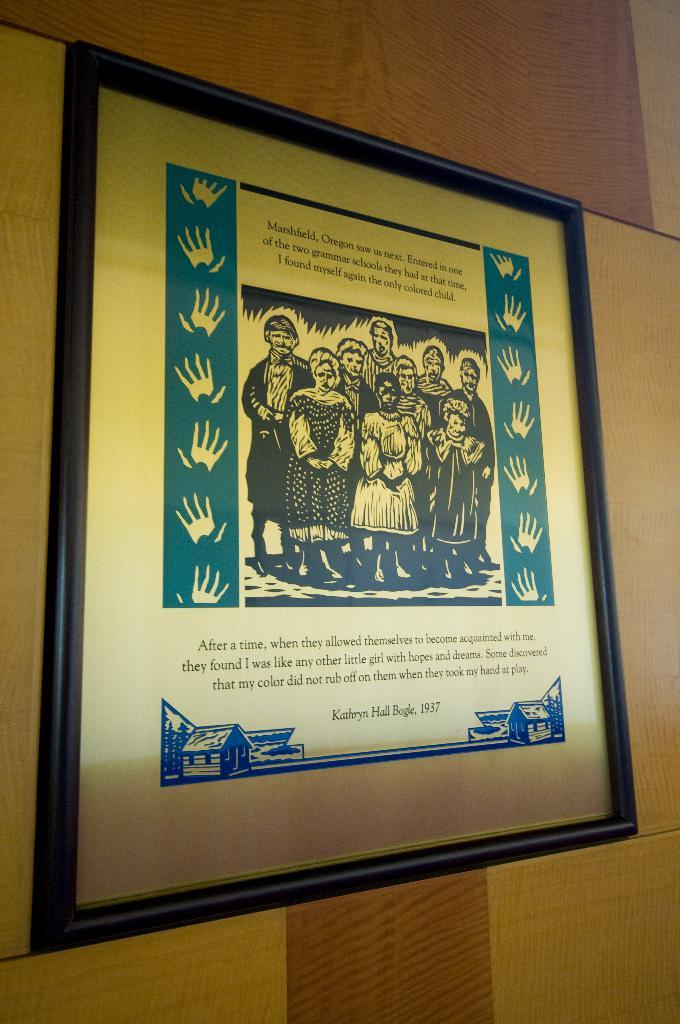<image>
Give a short and clear explanation of the subsequent image. Framed photo of a group of people and the name "Kathryn Hall Bogle" on the bottom. 